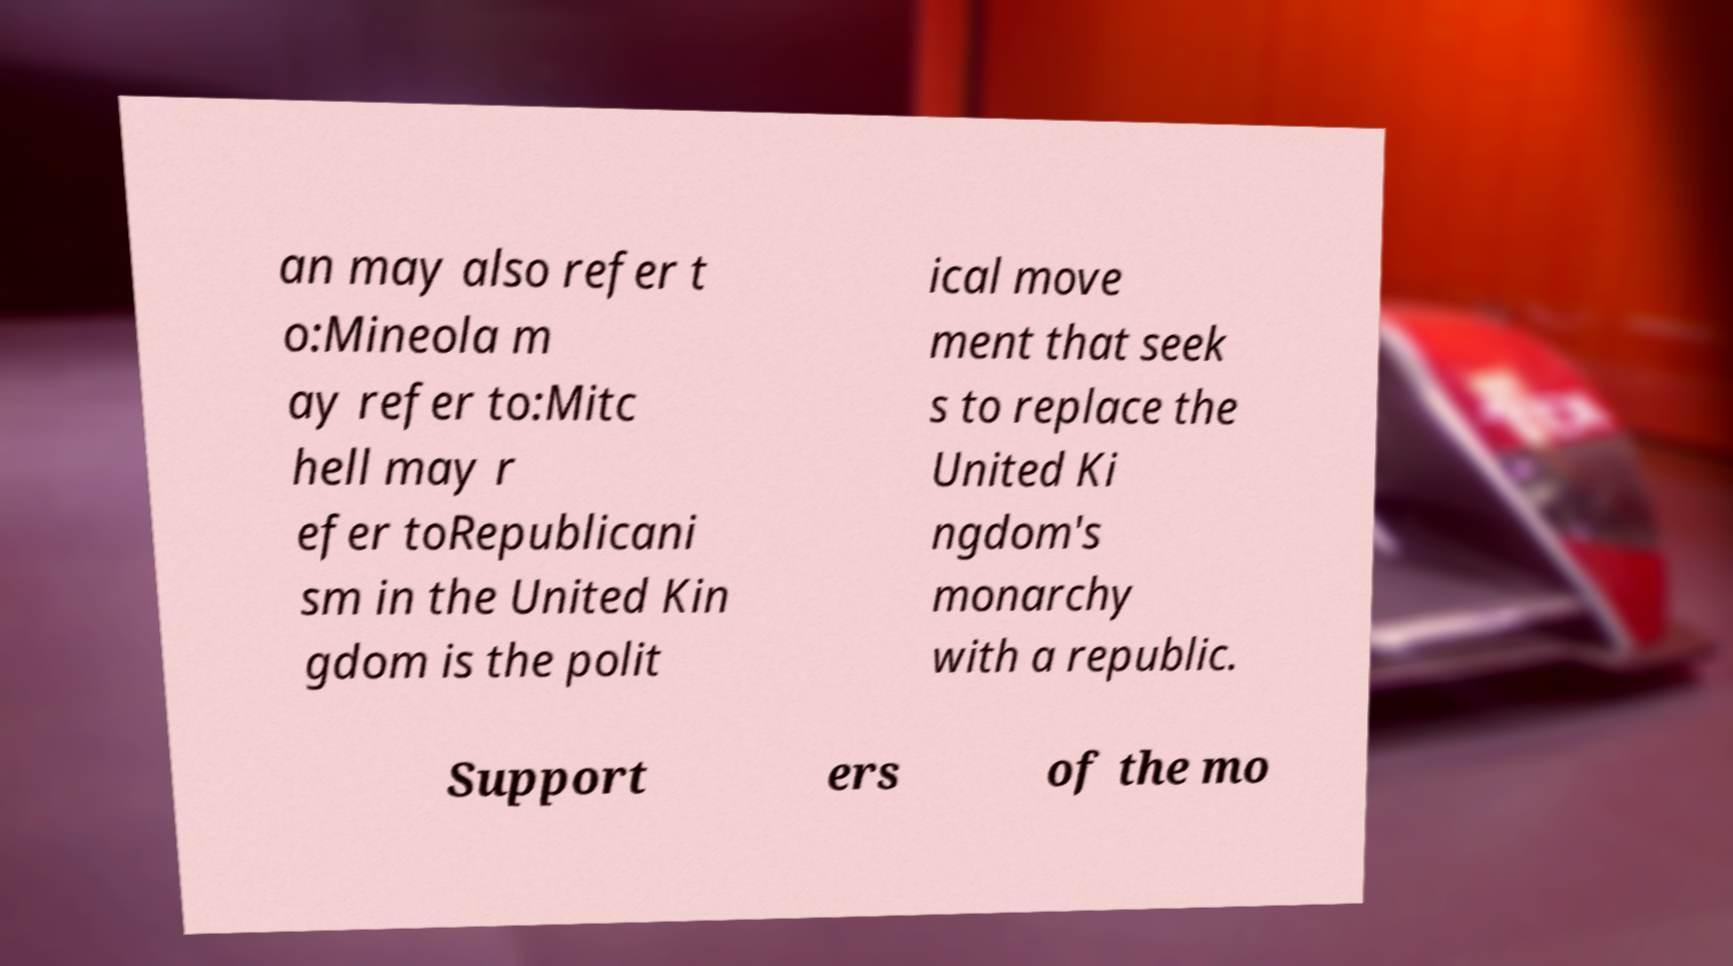Could you extract and type out the text from this image? an may also refer t o:Mineola m ay refer to:Mitc hell may r efer toRepublicani sm in the United Kin gdom is the polit ical move ment that seek s to replace the United Ki ngdom's monarchy with a republic. Support ers of the mo 